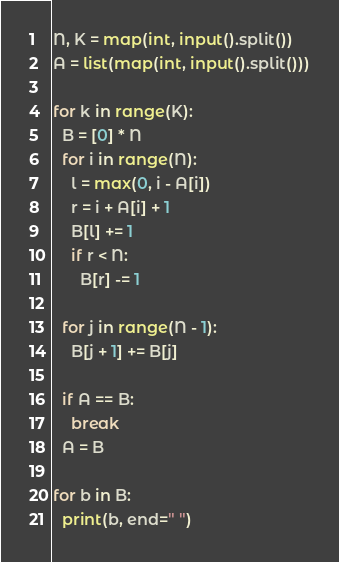Convert code to text. <code><loc_0><loc_0><loc_500><loc_500><_Python_>N, K = map(int, input().split())
A = list(map(int, input().split()))

for k in range(K):
  B = [0] * N
  for i in range(N):
    l = max(0, i - A[i])
    r = i + A[i] + 1
    B[l] += 1
    if r < N:
      B[r] -= 1

  for j in range(N - 1):
    B[j + 1] += B[j]
  
  if A == B:
    break
  A = B
  
for b in B:
  print(b, end=" ")</code> 